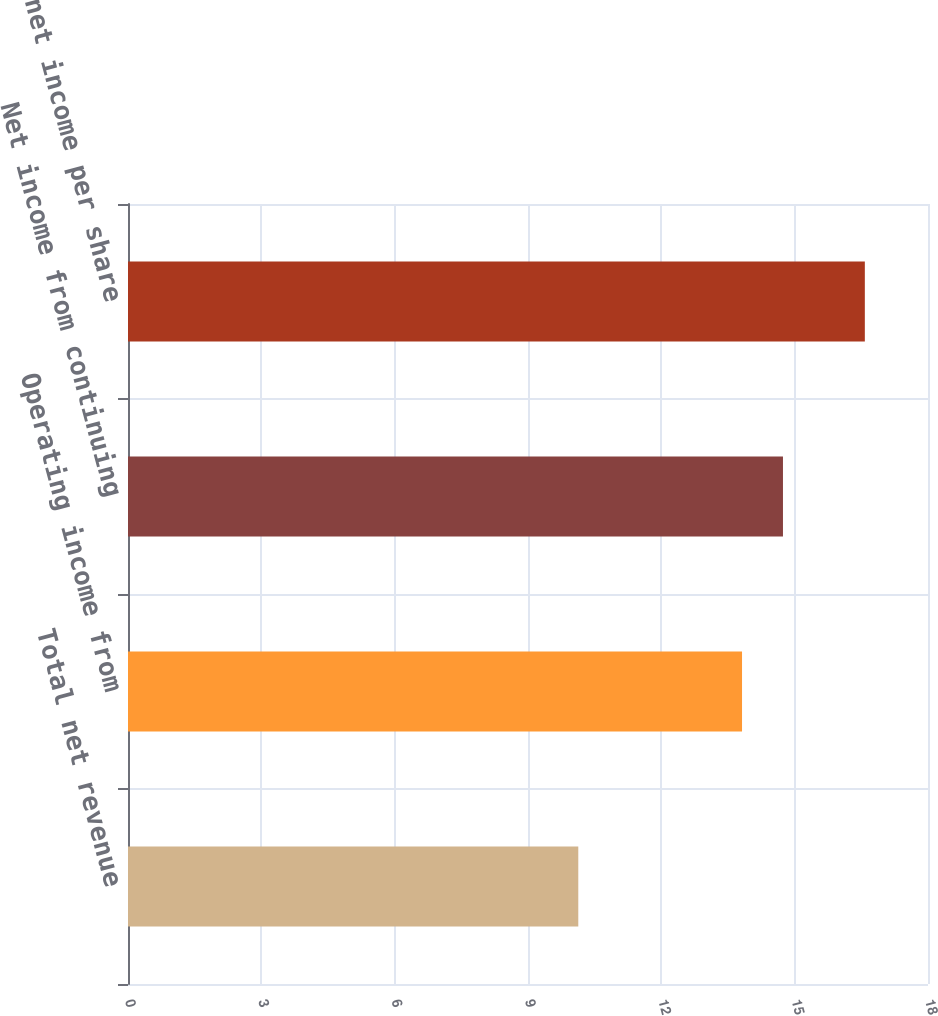Convert chart. <chart><loc_0><loc_0><loc_500><loc_500><bar_chart><fcel>Total net revenue<fcel>Operating income from<fcel>Net income from continuing<fcel>Diluted net income per share<nl><fcel>11<fcel>15<fcel>16<fcel>18<nl></chart> 